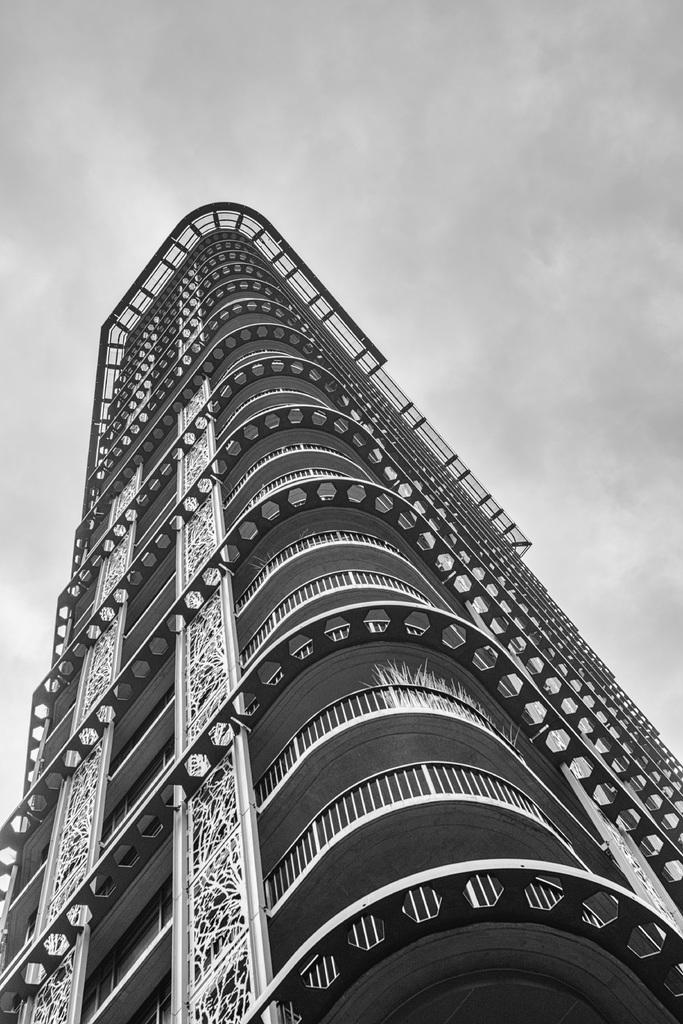What type of photo is in the image? There is a black and white photo in the image. What does the photo depict? The photo depicts a big building. What architectural features can be seen in the building? The building has iron frames and a balcony. What is visible at the top of the image? The sky is visible at the top of the image. How many fish are swimming in the balcony of the building in the image? There are no fish present in the image, and the balcony is not depicted as a body of water where fish could swim. 